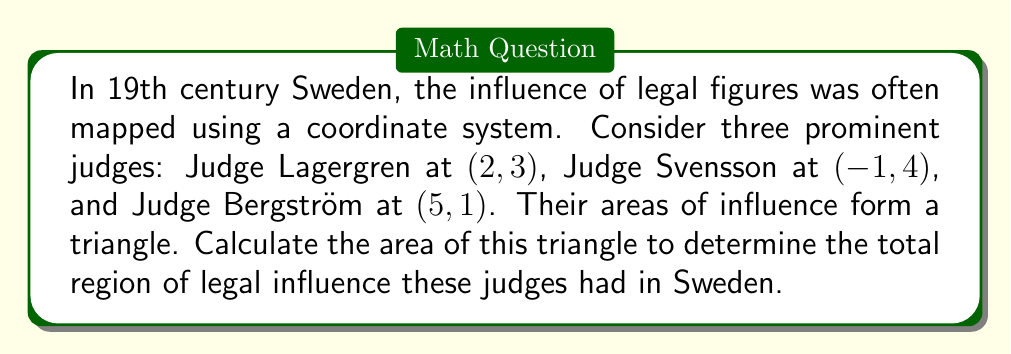Show me your answer to this math problem. To solve this problem, we'll use the formula for the area of a triangle given the coordinates of its vertices. This method is particularly useful when dealing with historical mapping of influence.

The formula for the area of a triangle given three points $(x_1, y_1)$, $(x_2, y_2)$, and $(x_3, y_3)$ is:

$$ \text{Area} = \frac{1}{2}|x_1(y_2 - y_3) + x_2(y_3 - y_1) + x_3(y_1 - y_2)| $$

Let's assign our points:
$(x_1, y_1) = (2, 3)$ for Judge Lagergren
$(x_2, y_2) = (-1, 4)$ for Judge Svensson
$(x_3, y_3) = (5, 1)$ for Judge Bergström

Now, let's substitute these values into our formula:

$$ \text{Area} = \frac{1}{2}|2(4 - 1) + (-1)(1 - 3) + 5(3 - 4)| $$

$$ = \frac{1}{2}|2(3) + (-1)(-2) + 5(-1)| $$

$$ = \frac{1}{2}|6 + 2 - 5| $$

$$ = \frac{1}{2}|3| $$

$$ = \frac{1}{2}(3) $$

$$ = 1.5 $$

Therefore, the area of influence is 1.5 square units in the coordinate system used to map legal influence in 19th century Sweden.
Answer: 1.5 square units 